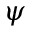Convert formula to latex. <formula><loc_0><loc_0><loc_500><loc_500>\psi</formula> 